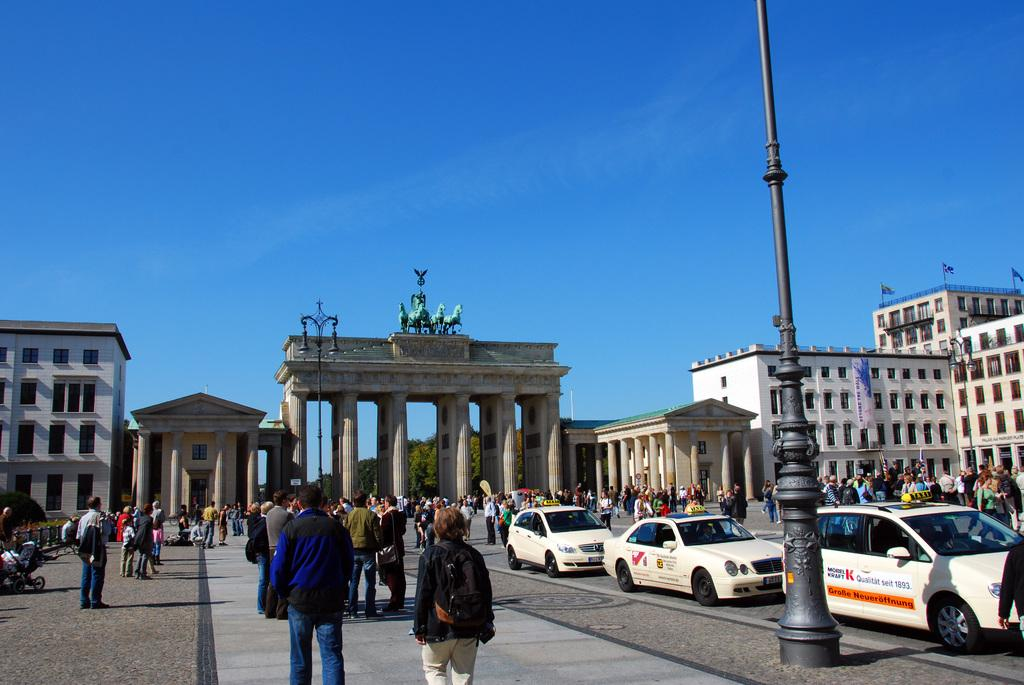What can be seen in the foreground of the picture? In the foreground of the picture, there are people, cars, a pool, and a road. What is located in the middle of the picture? In the middle of the picture, there are buildings and trees. What is visible at the top of the picture? The sky is visible at the top of the picture. Can you tell me how many baseballs are on the oven in the picture? There is no oven or baseballs present in the image. What type of print can be seen on the trees in the middle of the picture? There is no print on the trees in the image; they are natural trees. 